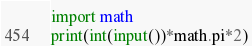<code> <loc_0><loc_0><loc_500><loc_500><_Python_>import math
print(int(input())*math.pi*2)</code> 